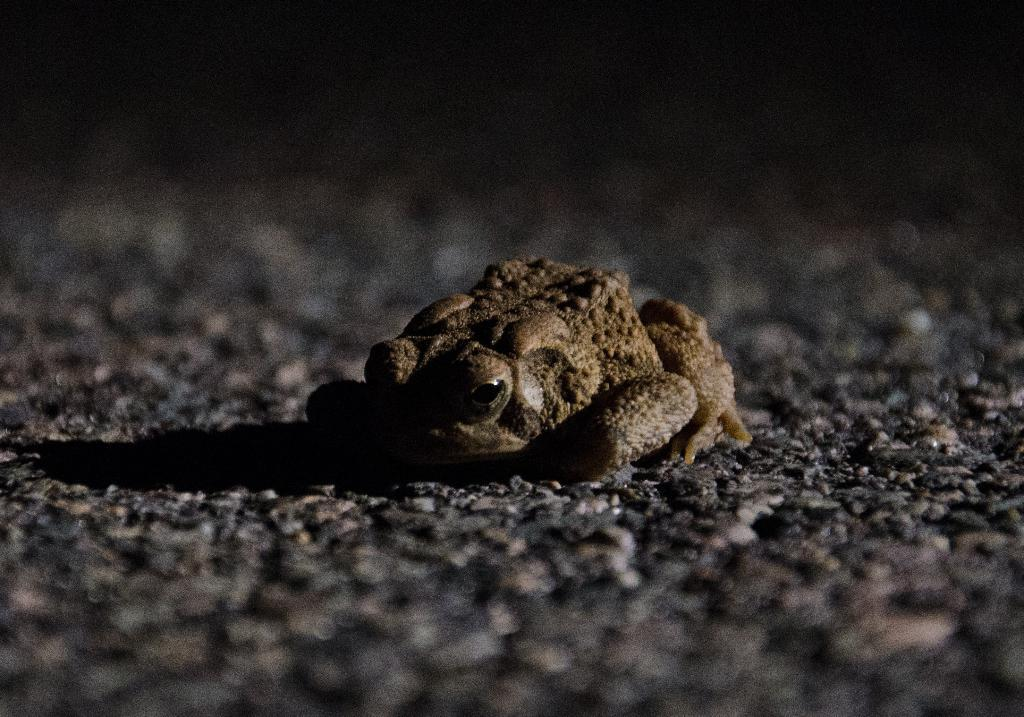What type of animal can be seen in the image? There is a frog in the image. What type of pathway is visible in the image? There is a road in the image. What type of lock is holding the frog in the image? There is: There is no lock present in the image, and the frog is not being held by any object. 